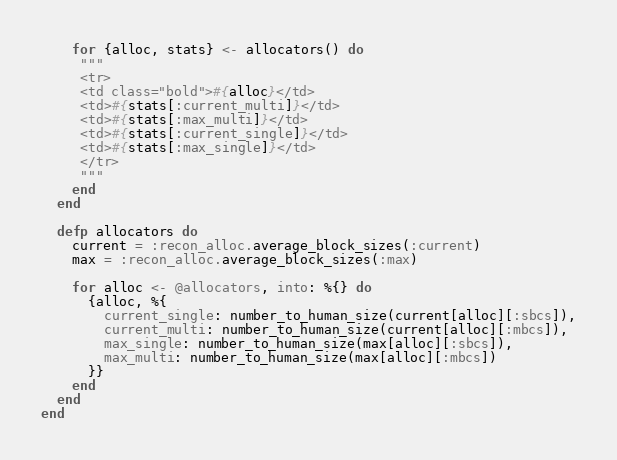Convert code to text. <code><loc_0><loc_0><loc_500><loc_500><_Elixir_>
    for {alloc, stats} <- allocators() do
     """
     <tr>
     <td class="bold">#{alloc}</td>
     <td>#{stats[:current_multi]}</td>
     <td>#{stats[:max_multi]}</td>
     <td>#{stats[:current_single]}</td>
     <td>#{stats[:max_single]}</td>
     </tr>
     """
    end
  end

  defp allocators do
    current = :recon_alloc.average_block_sizes(:current)
    max = :recon_alloc.average_block_sizes(:max)

    for alloc <- @allocators, into: %{} do
      {alloc, %{
        current_single: number_to_human_size(current[alloc][:sbcs]),
        current_multi: number_to_human_size(current[alloc][:mbcs]),
        max_single: number_to_human_size(max[alloc][:sbcs]),
        max_multi: number_to_human_size(max[alloc][:mbcs])
      }}
    end
  end
end
</code> 